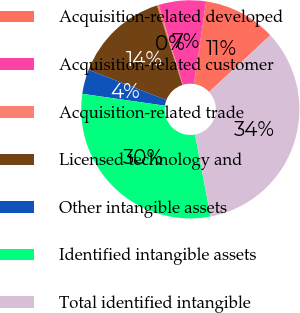Convert chart. <chart><loc_0><loc_0><loc_500><loc_500><pie_chart><fcel>Acquisition-related developed<fcel>Acquisition-related customer<fcel>Acquisition-related trade<fcel>Licensed technology and<fcel>Other intangible assets<fcel>Identified intangible assets<fcel>Total identified intangible<nl><fcel>10.8%<fcel>6.99%<fcel>0.26%<fcel>14.16%<fcel>3.63%<fcel>30.25%<fcel>33.9%<nl></chart> 